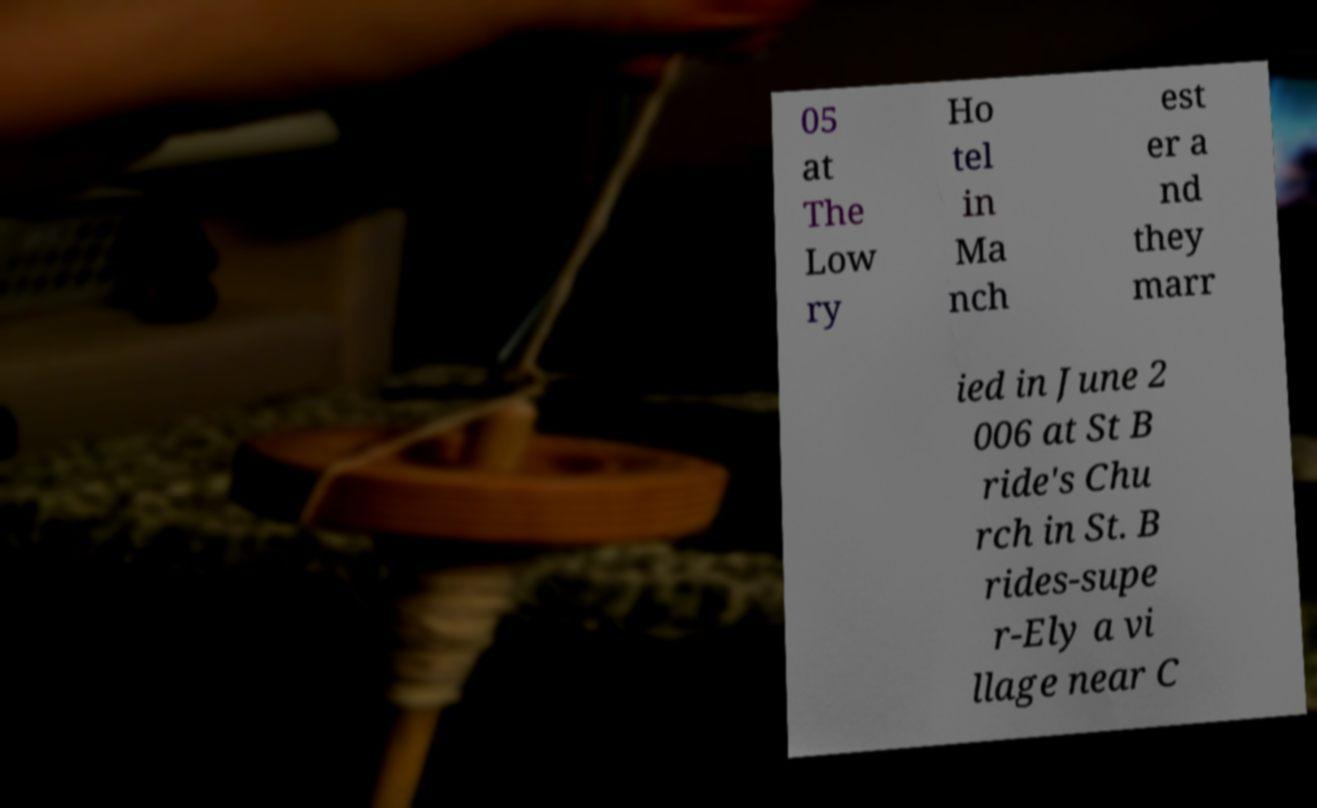Could you assist in decoding the text presented in this image and type it out clearly? 05 at The Low ry Ho tel in Ma nch est er a nd they marr ied in June 2 006 at St B ride's Chu rch in St. B rides-supe r-Ely a vi llage near C 